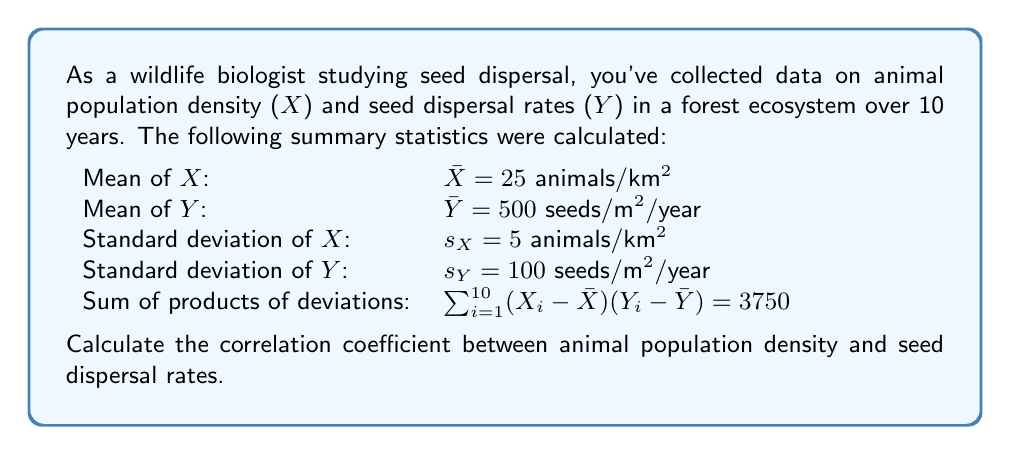Solve this math problem. To calculate the correlation coefficient between animal population density (X) and seed dispersal rates (Y), we'll use the Pearson correlation coefficient formula:

$$r = \frac{\sum_{i=1}^{n} (X_i - \bar{X})(Y_i - \bar{Y})}{(n-1)s_X s_Y}$$

Where:
- $n$ is the number of observations (10 years in this case)
- $s_X$ and $s_Y$ are the sample standard deviations of X and Y, respectively
- $\bar{X}$ and $\bar{Y}$ are the sample means of X and Y, respectively

We're given all the necessary information:
- $\sum_{i=1}^{10} (X_i - \bar{X})(Y_i - \bar{Y}) = 3750$
- $n = 10$
- $s_X = 5$ animals/km²
- $s_Y = 100$ seeds/m²/year

Let's substitute these values into the formula:

$$r = \frac{3750}{(10-1) \cdot 5 \cdot 100}$$

$$r = \frac{3750}{4500}$$

$$r = 0.8333$$

The correlation coefficient is always between -1 and 1. A value of 0.8333 indicates a strong positive correlation between animal population density and seed dispersal rates.
Answer: $r = 0.8333$ 